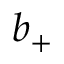<formula> <loc_0><loc_0><loc_500><loc_500>b _ { + }</formula> 